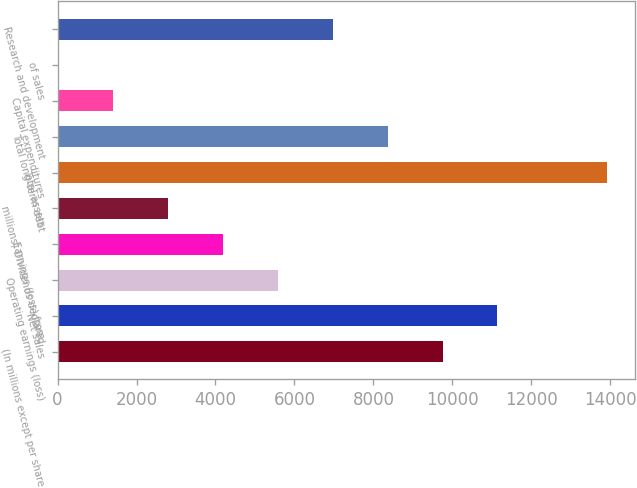Convert chart. <chart><loc_0><loc_0><loc_500><loc_500><bar_chart><fcel>(In millions except per share<fcel>Net sales<fcel>Operating earnings (loss)<fcel>Earnings (loss) from<fcel>millions) Dividends declared<fcel>Total assets<fcel>Total long-term debt<fcel>Capital expenditures<fcel>of sales<fcel>Research and development<nl><fcel>9751.17<fcel>11143.8<fcel>5573.34<fcel>4180.73<fcel>2788.12<fcel>13929<fcel>8358.56<fcel>1395.51<fcel>2.9<fcel>6965.95<nl></chart> 